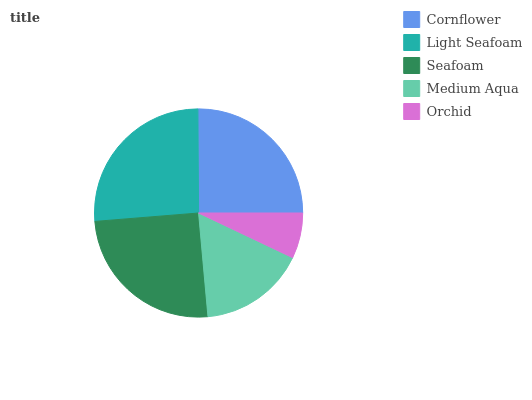Is Orchid the minimum?
Answer yes or no. Yes. Is Light Seafoam the maximum?
Answer yes or no. Yes. Is Seafoam the minimum?
Answer yes or no. No. Is Seafoam the maximum?
Answer yes or no. No. Is Light Seafoam greater than Seafoam?
Answer yes or no. Yes. Is Seafoam less than Light Seafoam?
Answer yes or no. Yes. Is Seafoam greater than Light Seafoam?
Answer yes or no. No. Is Light Seafoam less than Seafoam?
Answer yes or no. No. Is Cornflower the high median?
Answer yes or no. Yes. Is Cornflower the low median?
Answer yes or no. Yes. Is Orchid the high median?
Answer yes or no. No. Is Light Seafoam the low median?
Answer yes or no. No. 